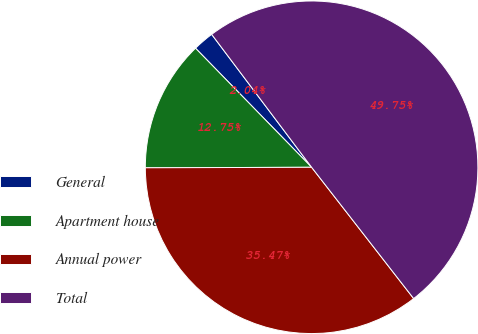<chart> <loc_0><loc_0><loc_500><loc_500><pie_chart><fcel>General<fcel>Apartment house<fcel>Annual power<fcel>Total<nl><fcel>2.04%<fcel>12.75%<fcel>35.47%<fcel>49.75%<nl></chart> 